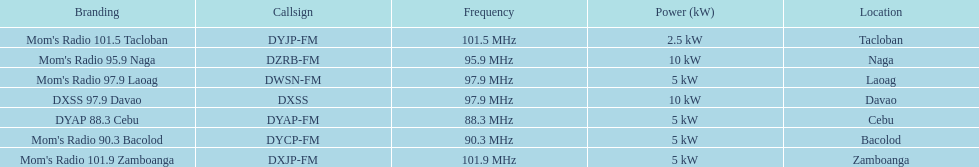Which stations use less than 10kw of power? Mom's Radio 97.9 Laoag, Mom's Radio 90.3 Bacolod, DYAP 88.3 Cebu, Mom's Radio 101.5 Tacloban, Mom's Radio 101.9 Zamboanga. Do any stations use less than 5kw of power? if so, which ones? Mom's Radio 101.5 Tacloban. 